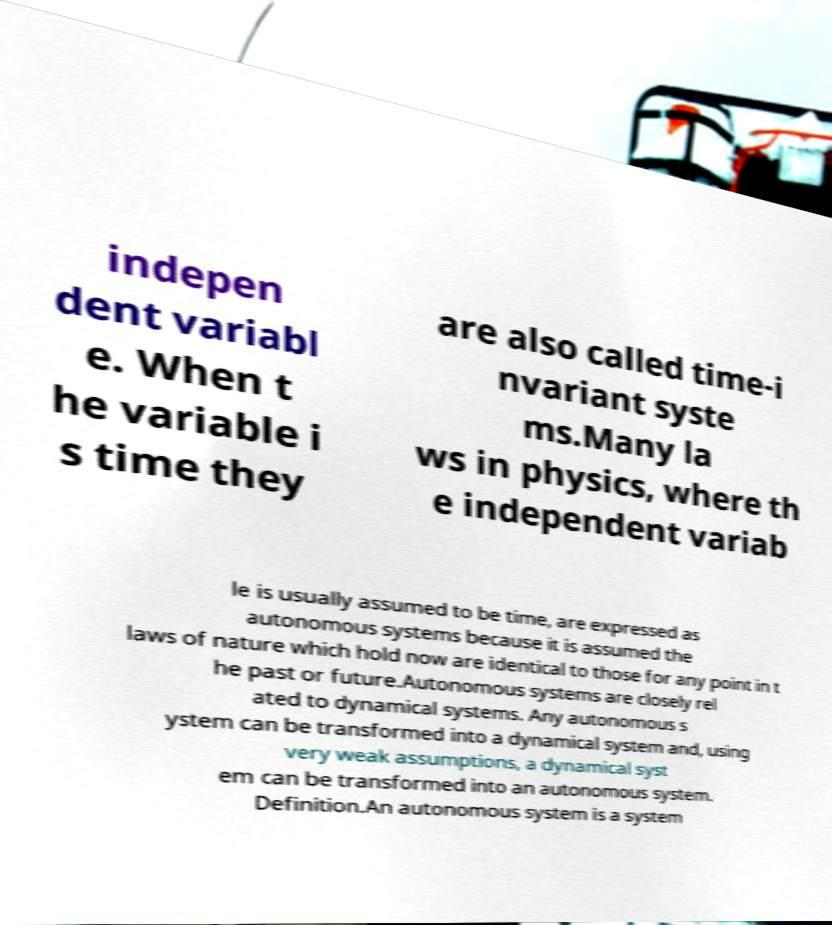Please read and relay the text visible in this image. What does it say? indepen dent variabl e. When t he variable i s time they are also called time-i nvariant syste ms.Many la ws in physics, where th e independent variab le is usually assumed to be time, are expressed as autonomous systems because it is assumed the laws of nature which hold now are identical to those for any point in t he past or future.Autonomous systems are closely rel ated to dynamical systems. Any autonomous s ystem can be transformed into a dynamical system and, using very weak assumptions, a dynamical syst em can be transformed into an autonomous system. Definition.An autonomous system is a system 